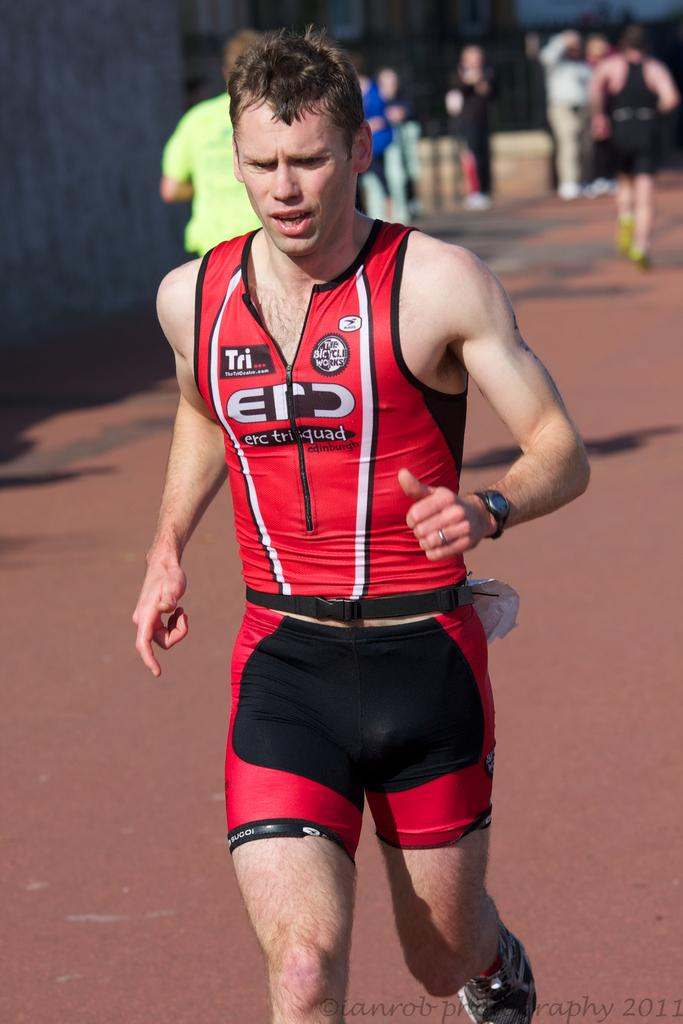<image>
Relay a brief, clear account of the picture shown. a man running a marathon with a shirt from thetricentre.com 